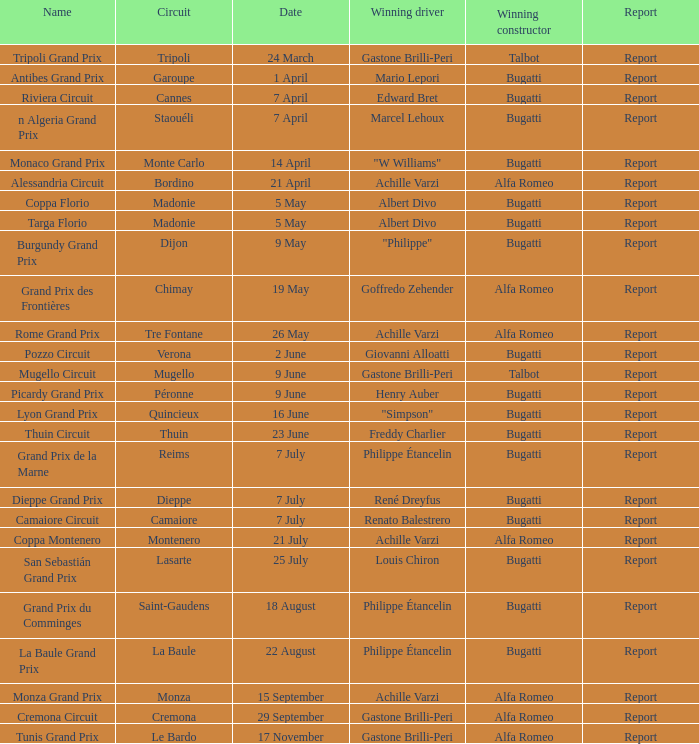What Winning driver has a Winning constructor of talbot? Gastone Brilli-Peri, Gastone Brilli-Peri. 